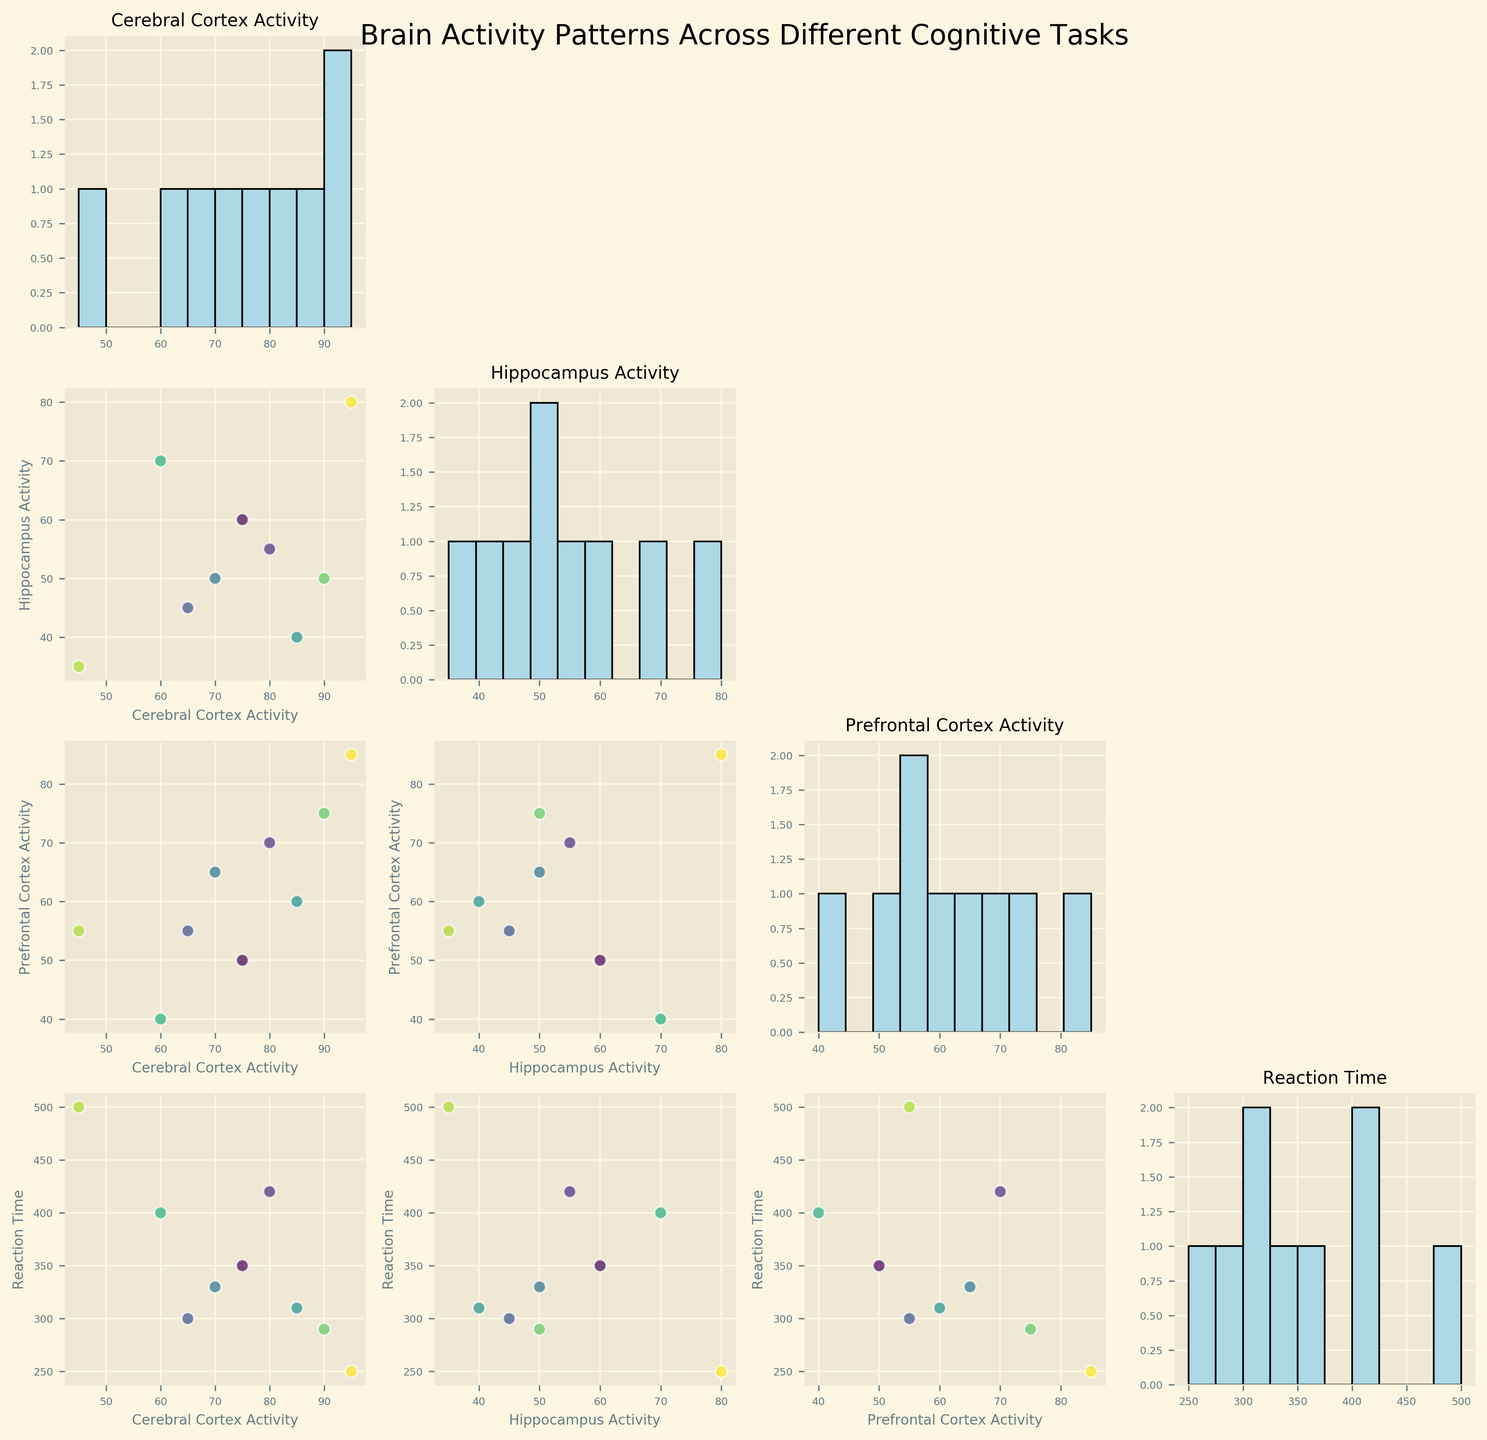What is the main title of the figure? The main title is typically found at the top of the figure, summarizing the content of the scatter plot matrix. Here, it reads "Brain Activity Patterns Across Different Cognitive Tasks".
Answer: Brain Activity Patterns Across Different Cognitive Tasks How many cognitive tasks are represented in the figure? Look at the scatter plots; each data point represents a cognitive task. Counting the data points in any of the scatter plots will give the number of tasks. Here, there are 9 tasks.
Answer: 9 Which cognitive task has the highest Cerebral Cortex Activity? Find the scatter plot where the x-axis or y-axis represents "Cerebral Cortex Activity". Look for the highest data point along that axis. In this case, "High-Stress Task" has the highest value (95).
Answer: High-Stress Task How does Reaction Time compare for "Memory Recall" and "Problem Solving"? Find the scatter plots involving "Reaction Time" and identify the points for "Memory Recall" and "Problem Solving". "Memory Recall" has a Reaction Time of 350, and "Problem Solving" has 420. Thus, "Problem Solving" has a longer Reaction Time.
Answer: Problem Solving has a longer Reaction Time What is the average Prefrontal Cortex Activity across all tasks? Look at the histogram for "Prefrontal Cortex Activity" and note the values. The average is calculated as (50+70+55+65+60+40+75+55+85)/9 = 61.7.
Answer: 61.7 What is the relationship between Hippocampus Activity and Reaction Time? Look at the scatter plot where "Hippocampus Activity" is plotted against "Reaction Time". Generally, as Hippocampus Activity increases, the Reaction Time decreases (inverse relationship).
Answer: Inverse relationship Which pair of activities shows the most similar pattern in Cerebral Cortex Activity and Hippocampus Activity? Compare the scatter plot points for "Cerebral Cortex Activity" vs. "Hippocampus Activity". "Motor Control" (85, 40) and "Attention Focus" (90, 50) show a similar trend.
Answer: Motor Control and Attention Focus What trend is visible in the scatter plot for "Cerebral Cortex Activity" against "Prefrontal Cortex Activity"? Observe the direction of the data points in the scatter plot where "Cerebral Cortex Activity" is on one axis and "Prefrontal Cortex Activity" on the other. There is a positive trend, indicating that as Cerebral Cortex Activity increases, Prefrontal Cortex Activity also tends to increase.
Answer: Positive trend Which scatter plot shows the strongest correlation between its variables? By visually inspecting the scatter plots, we see that "Cerebral Cortex Activity" vs. "Prefrontal Cortex Activity" has a strong positive linear correlation, more so than other pairs.
Answer: Cerebral Cortex Activity vs. Prefrontal Cortex Activity Which tasks have both lower than average values in both Cerebral Cortex Activity and Hippocampus Activity? Find tasks with values lower than the average of each section using the histrograms, and then identify the corresponding tasks in the scatter plot matrix of "Cerebral Cortex Activity" vs. "Hippocampus Activity". "Meditation" (45, 35) fits both criteria.
Answer: Meditation 